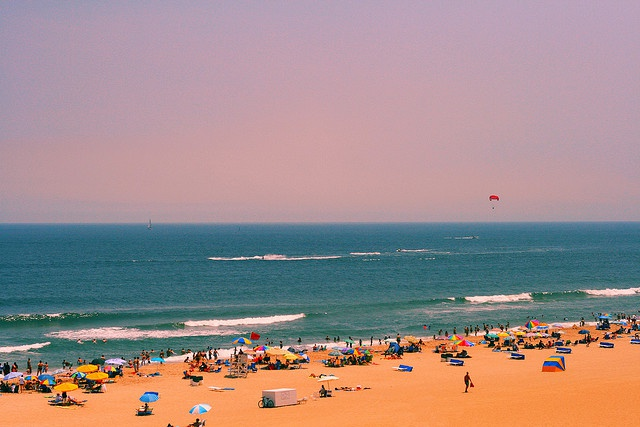Describe the objects in this image and their specific colors. I can see people in gray, orange, teal, and black tones, umbrella in darkgray, orange, gray, lavender, and black tones, umbrella in darkgray, orange, red, and gold tones, bicycle in darkgray, black, gray, orange, and teal tones, and umbrella in darkgray, orange, gold, and red tones in this image. 